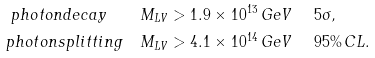Convert formula to latex. <formula><loc_0><loc_0><loc_500><loc_500>p h o t o n d e c a y \quad & M _ { L V } > 1 . 9 \times 1 0 ^ { 1 3 } \, G e V \quad \ 5 \sigma , \\ p h o t o n s p l i t t i n g \quad & M _ { L V } > 4 . 1 \times 1 0 ^ { 1 4 } \, G e V \quad \ 9 5 \% \, C L .</formula> 